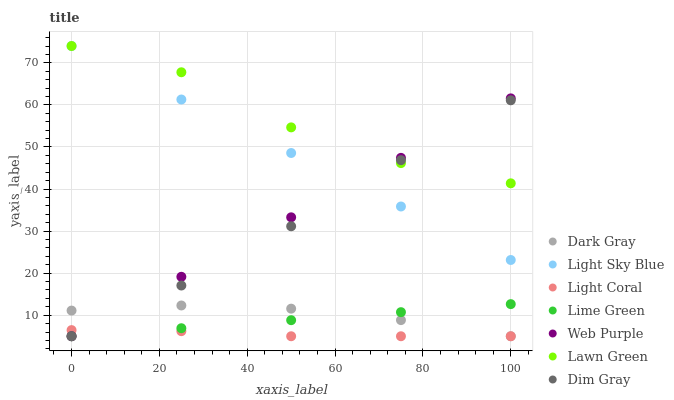Does Light Coral have the minimum area under the curve?
Answer yes or no. Yes. Does Lawn Green have the maximum area under the curve?
Answer yes or no. Yes. Does Dim Gray have the minimum area under the curve?
Answer yes or no. No. Does Dim Gray have the maximum area under the curve?
Answer yes or no. No. Is Light Sky Blue the smoothest?
Answer yes or no. Yes. Is Lawn Green the roughest?
Answer yes or no. Yes. Is Dim Gray the smoothest?
Answer yes or no. No. Is Dim Gray the roughest?
Answer yes or no. No. Does Light Coral have the lowest value?
Answer yes or no. Yes. Does Lawn Green have the lowest value?
Answer yes or no. No. Does Light Sky Blue have the highest value?
Answer yes or no. Yes. Does Dim Gray have the highest value?
Answer yes or no. No. Is Lime Green less than Lawn Green?
Answer yes or no. Yes. Is Lawn Green greater than Lime Green?
Answer yes or no. Yes. Does Dim Gray intersect Dark Gray?
Answer yes or no. Yes. Is Dim Gray less than Dark Gray?
Answer yes or no. No. Is Dim Gray greater than Dark Gray?
Answer yes or no. No. Does Lime Green intersect Lawn Green?
Answer yes or no. No. 